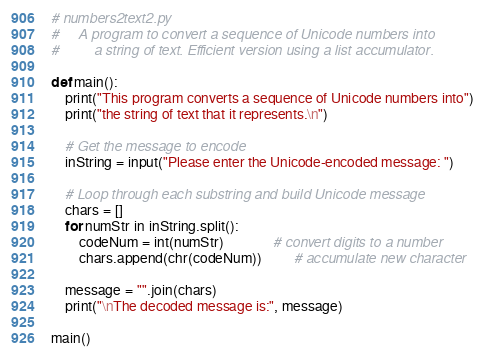Convert code to text. <code><loc_0><loc_0><loc_500><loc_500><_Python_># numbers2text2.py
#     A program to convert a sequence of Unicode numbers into
#         a string of text. Efficient version using a list accumulator.

def main():
    print("This program converts a sequence of Unicode numbers into")
    print("the string of text that it represents.\n")
    
    # Get the message to encode
    inString = input("Please enter the Unicode-encoded message: ")

    # Loop through each substring and build Unicode message
    chars = [] 
    for numStr in inString.split():
        codeNum = int(numStr)              # convert digits to a number
        chars.append(chr(codeNum))         # accumulate new character

    message = "".join(chars)
    print("\nThe decoded message is:", message)

main()
</code> 